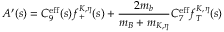Convert formula to latex. <formula><loc_0><loc_0><loc_500><loc_500>A ^ { \prime } ( s ) = C _ { 9 } ^ { e f f } ( s ) f _ { + } ^ { K , \eta } ( s ) + \frac { 2 m _ { b } } { m _ { B } + m _ { K , \eta } } C _ { 7 } ^ { e f f } f _ { T } ^ { K , \eta } ( s )</formula> 